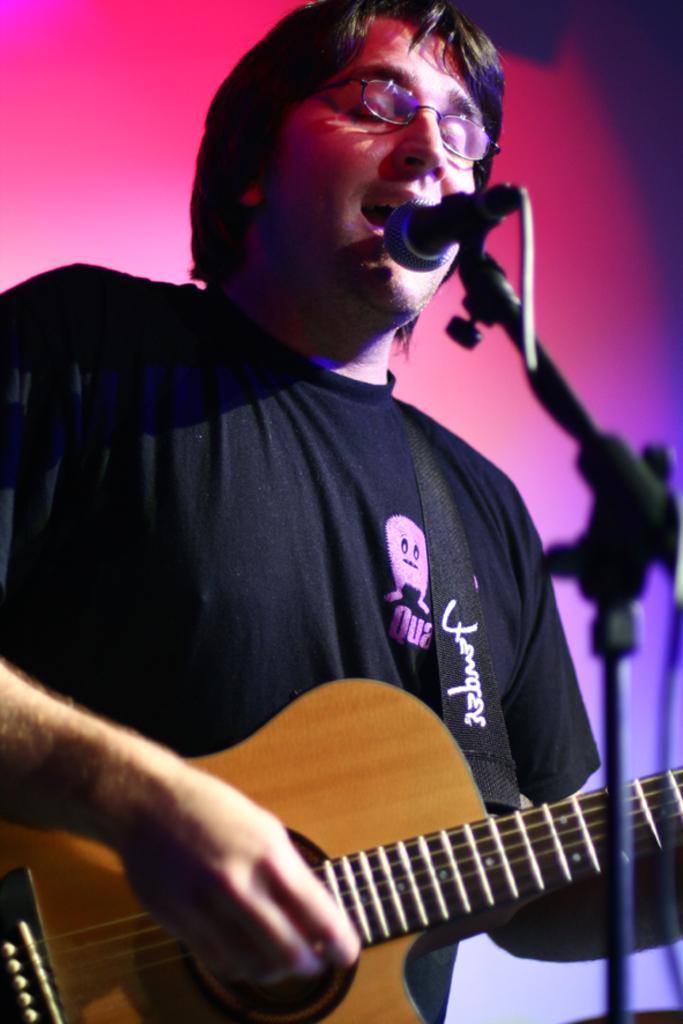In one or two sentences, can you explain what this image depicts? This picture shows a man singing and playing a guitar in his hands in front of a microphone and a stand. In the background there is a red color light. 